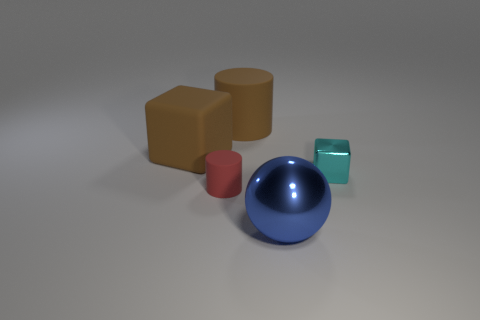Subtract all spheres. How many objects are left? 4 Add 3 small green cylinders. How many objects exist? 8 Subtract all cylinders. Subtract all shiny spheres. How many objects are left? 2 Add 1 large cylinders. How many large cylinders are left? 2 Add 1 cyan shiny things. How many cyan shiny things exist? 2 Subtract 0 brown spheres. How many objects are left? 5 